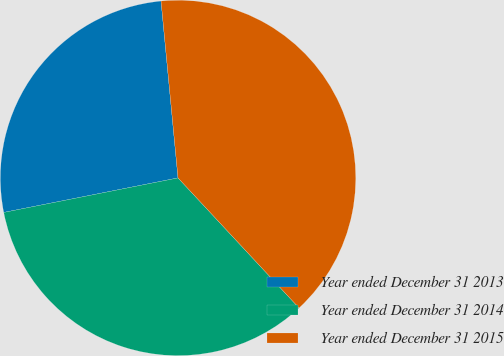Convert chart. <chart><loc_0><loc_0><loc_500><loc_500><pie_chart><fcel>Year ended December 31 2013<fcel>Year ended December 31 2014<fcel>Year ended December 31 2015<nl><fcel>26.59%<fcel>33.82%<fcel>39.6%<nl></chart> 